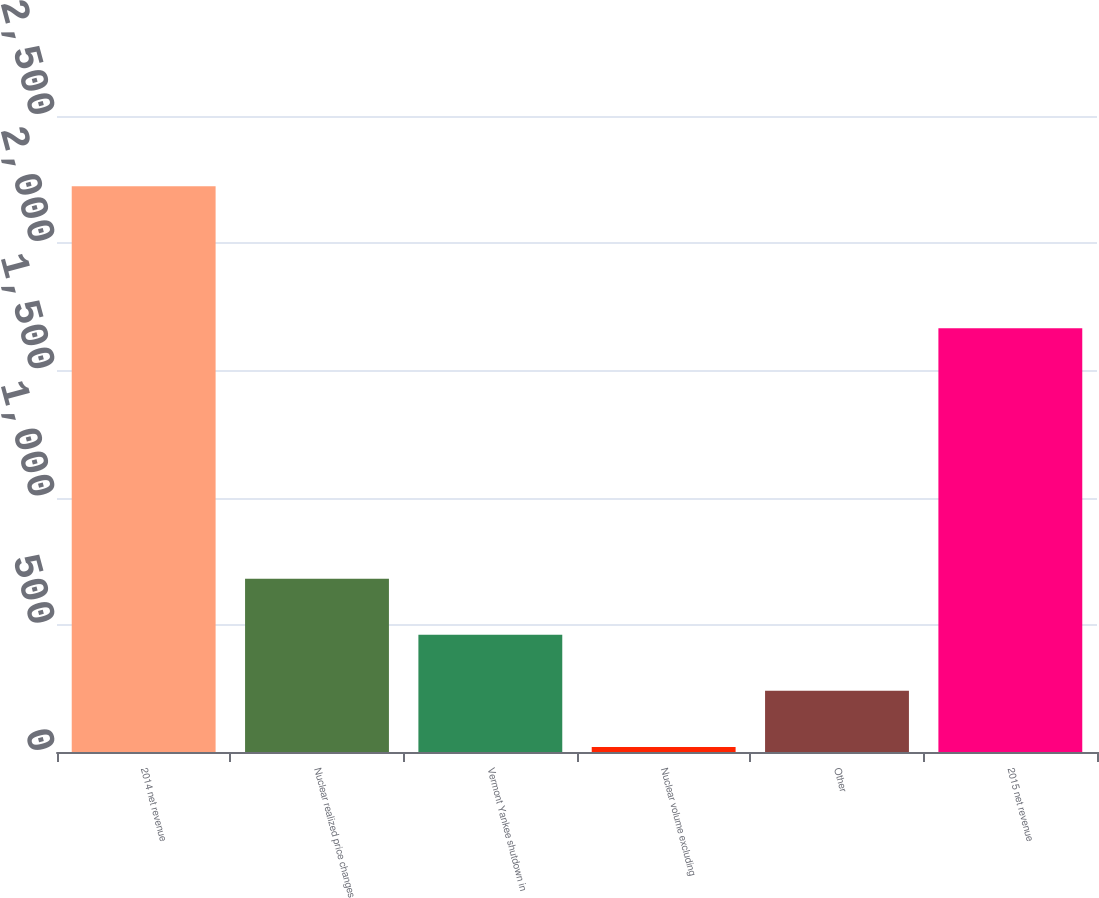Convert chart to OTSL. <chart><loc_0><loc_0><loc_500><loc_500><bar_chart><fcel>2014 net revenue<fcel>Nuclear realized price changes<fcel>Vermont Yankee shutdown in<fcel>Nuclear volume excluding<fcel>Other<fcel>2015 net revenue<nl><fcel>2224<fcel>681.2<fcel>460.8<fcel>20<fcel>240.4<fcel>1666<nl></chart> 